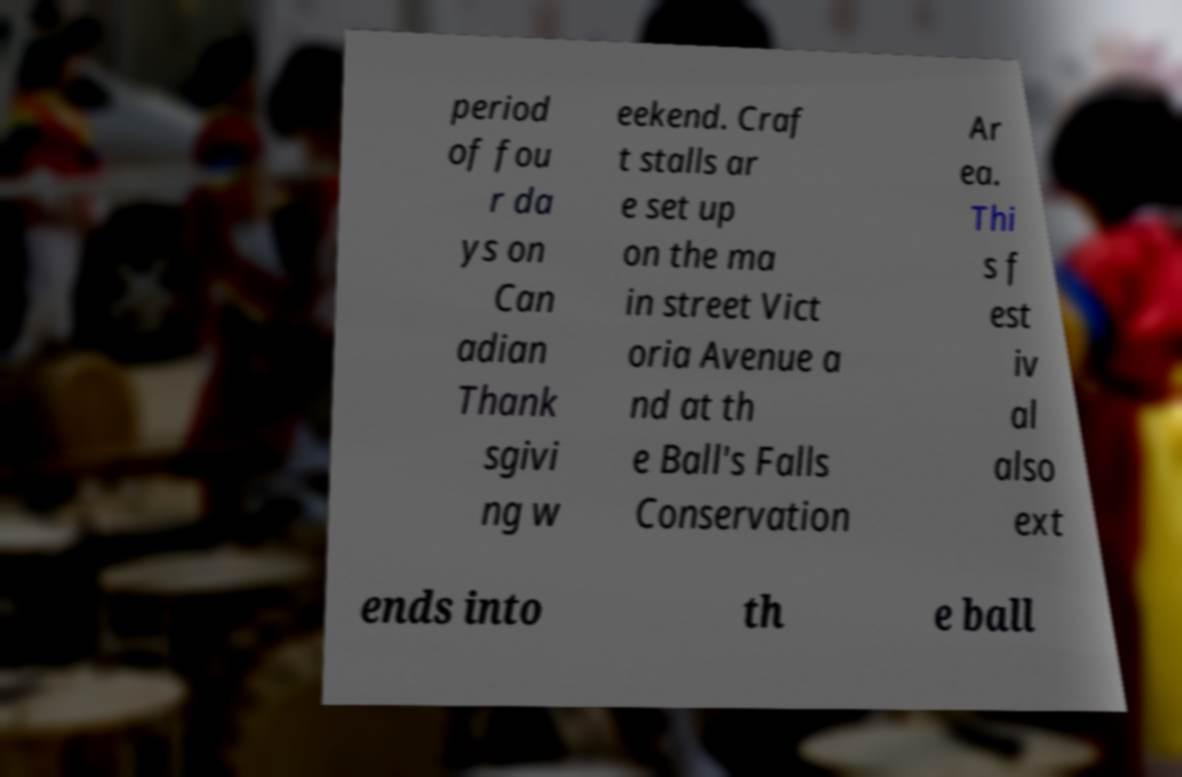Please identify and transcribe the text found in this image. period of fou r da ys on Can adian Thank sgivi ng w eekend. Craf t stalls ar e set up on the ma in street Vict oria Avenue a nd at th e Ball's Falls Conservation Ar ea. Thi s f est iv al also ext ends into th e ball 